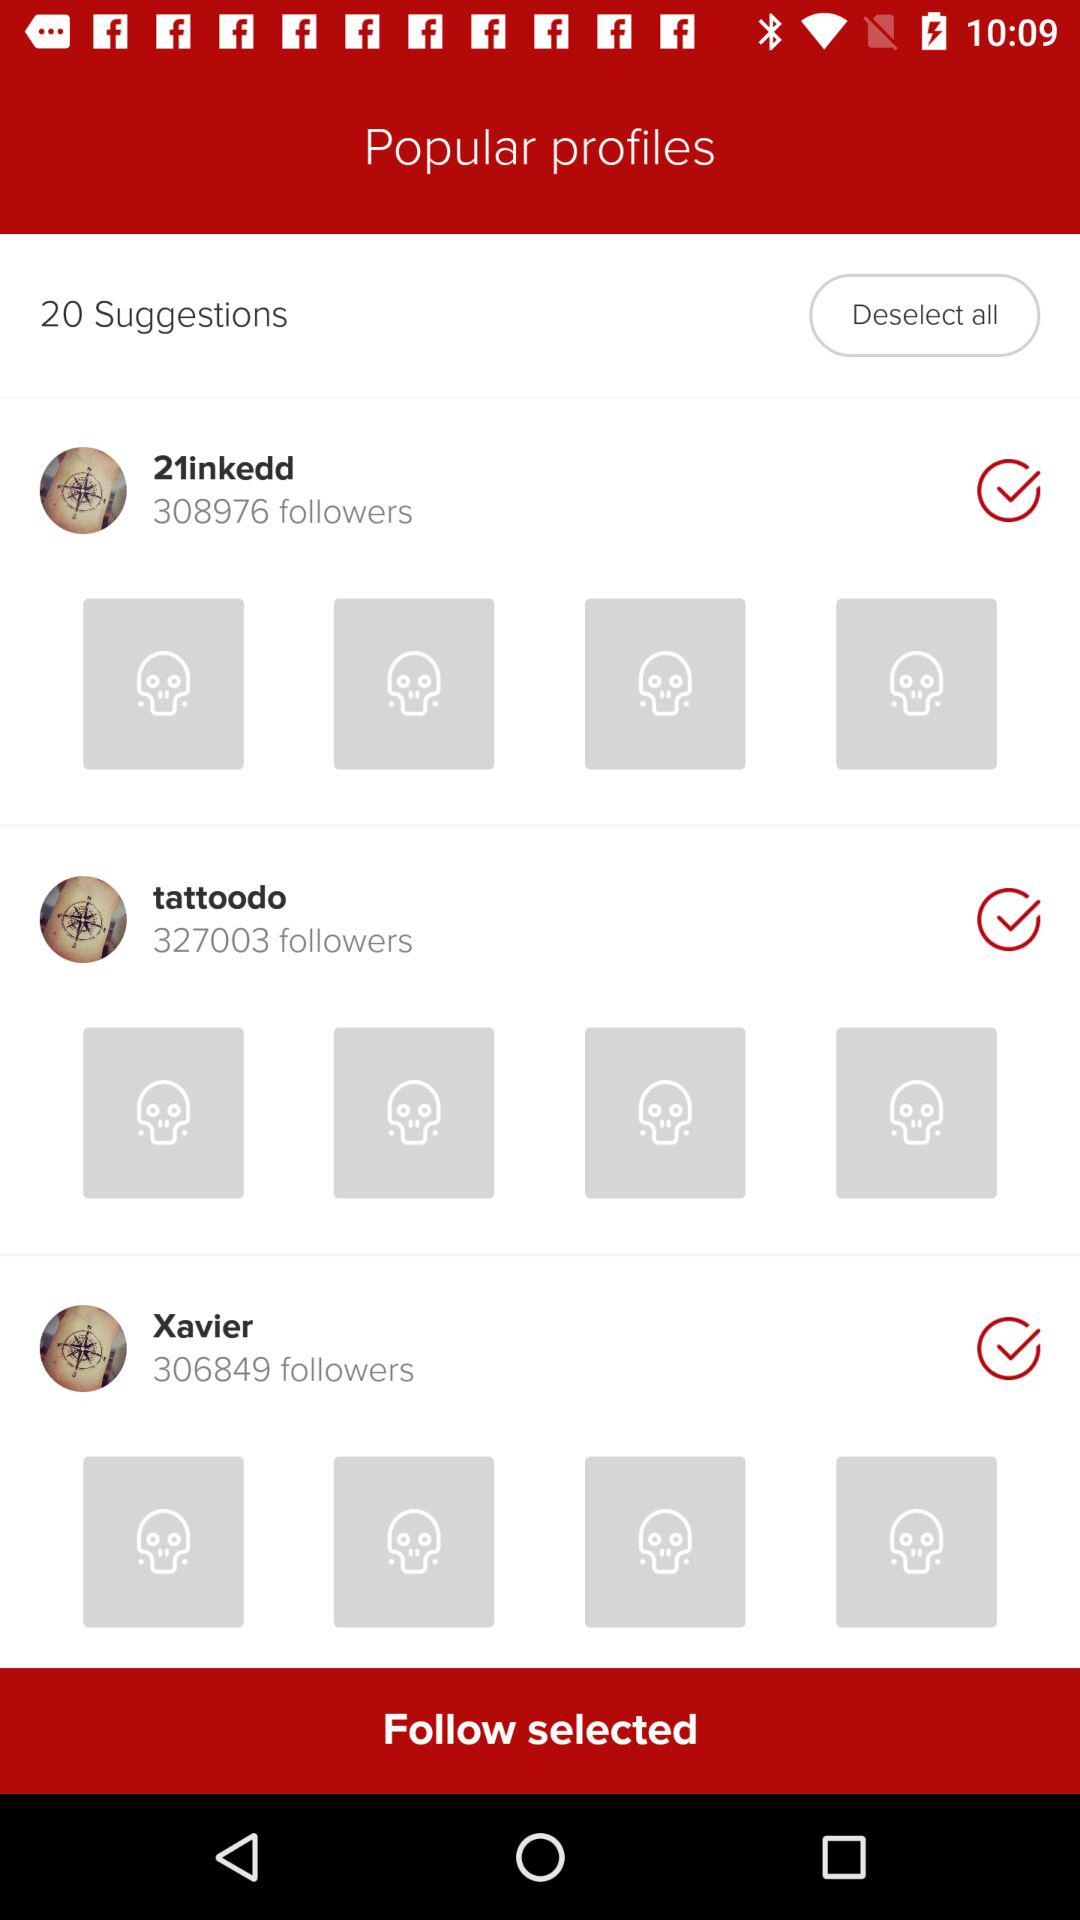How many followers does the user with the name Xavier have?
Answer the question using a single word or phrase. 306849 